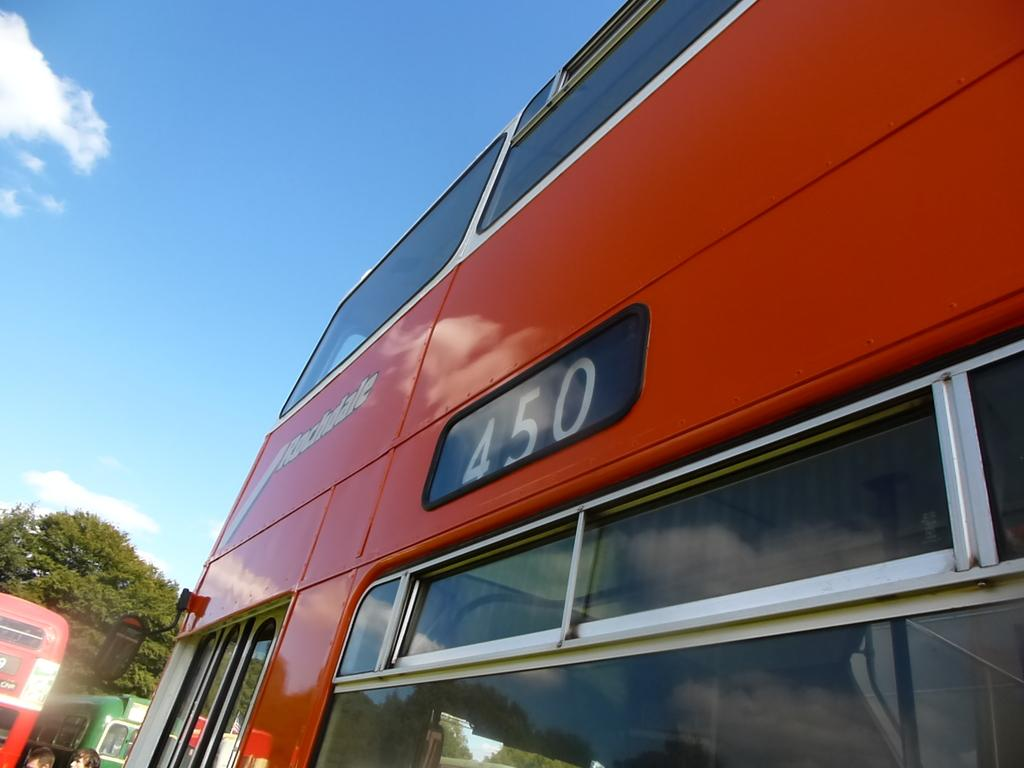What is the main subject of the image? The main subject of the image is three buses. What can be seen in the background of the image? There is a tree in the background of the image. Are there any people visible in the image? Yes, there are two persons at the left bottom of the image. What is visible at the top of the image? The sky is visible at the top of the image. What type of pig can be seen enjoying a vacation in the image? There is no pig or vacation present in the image; it features three buses, a tree, two persons, and the sky. 